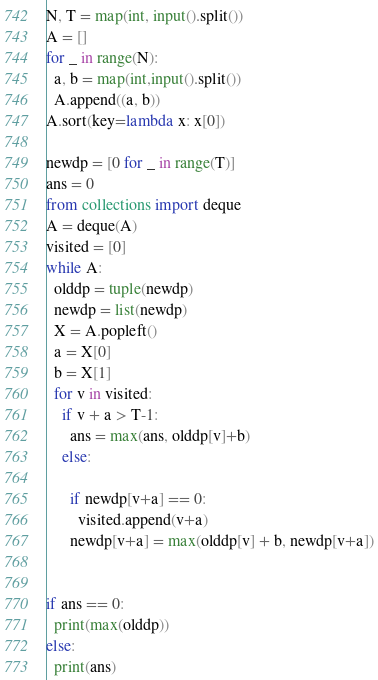Convert code to text. <code><loc_0><loc_0><loc_500><loc_500><_Python_>N, T = map(int, input().split())
A = []
for _ in range(N):
  a, b = map(int,input().split())
  A.append((a, b))
A.sort(key=lambda x: x[0])

newdp = [0 for _ in range(T)]
ans = 0
from collections import deque
A = deque(A)
visited = [0]
while A:
  olddp = tuple(newdp)
  newdp = list(newdp)
  X = A.popleft()
  a = X[0]
  b = X[1]
  for v in visited:
    if v + a > T-1:
      ans = max(ans, olddp[v]+b)
    else:

      if newdp[v+a] == 0:
        visited.append(v+a)
      newdp[v+a] = max(olddp[v] + b, newdp[v+a])


if ans == 0:
  print(max(olddp))
else:
  print(ans)</code> 